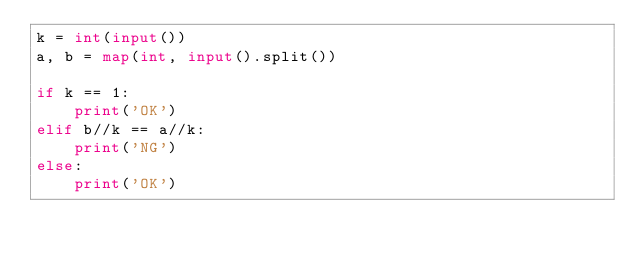Convert code to text. <code><loc_0><loc_0><loc_500><loc_500><_Python_>k = int(input())
a, b = map(int, input().split())

if k == 1:
    print('OK')
elif b//k == a//k:
    print('NG')
else:
    print('OK')</code> 